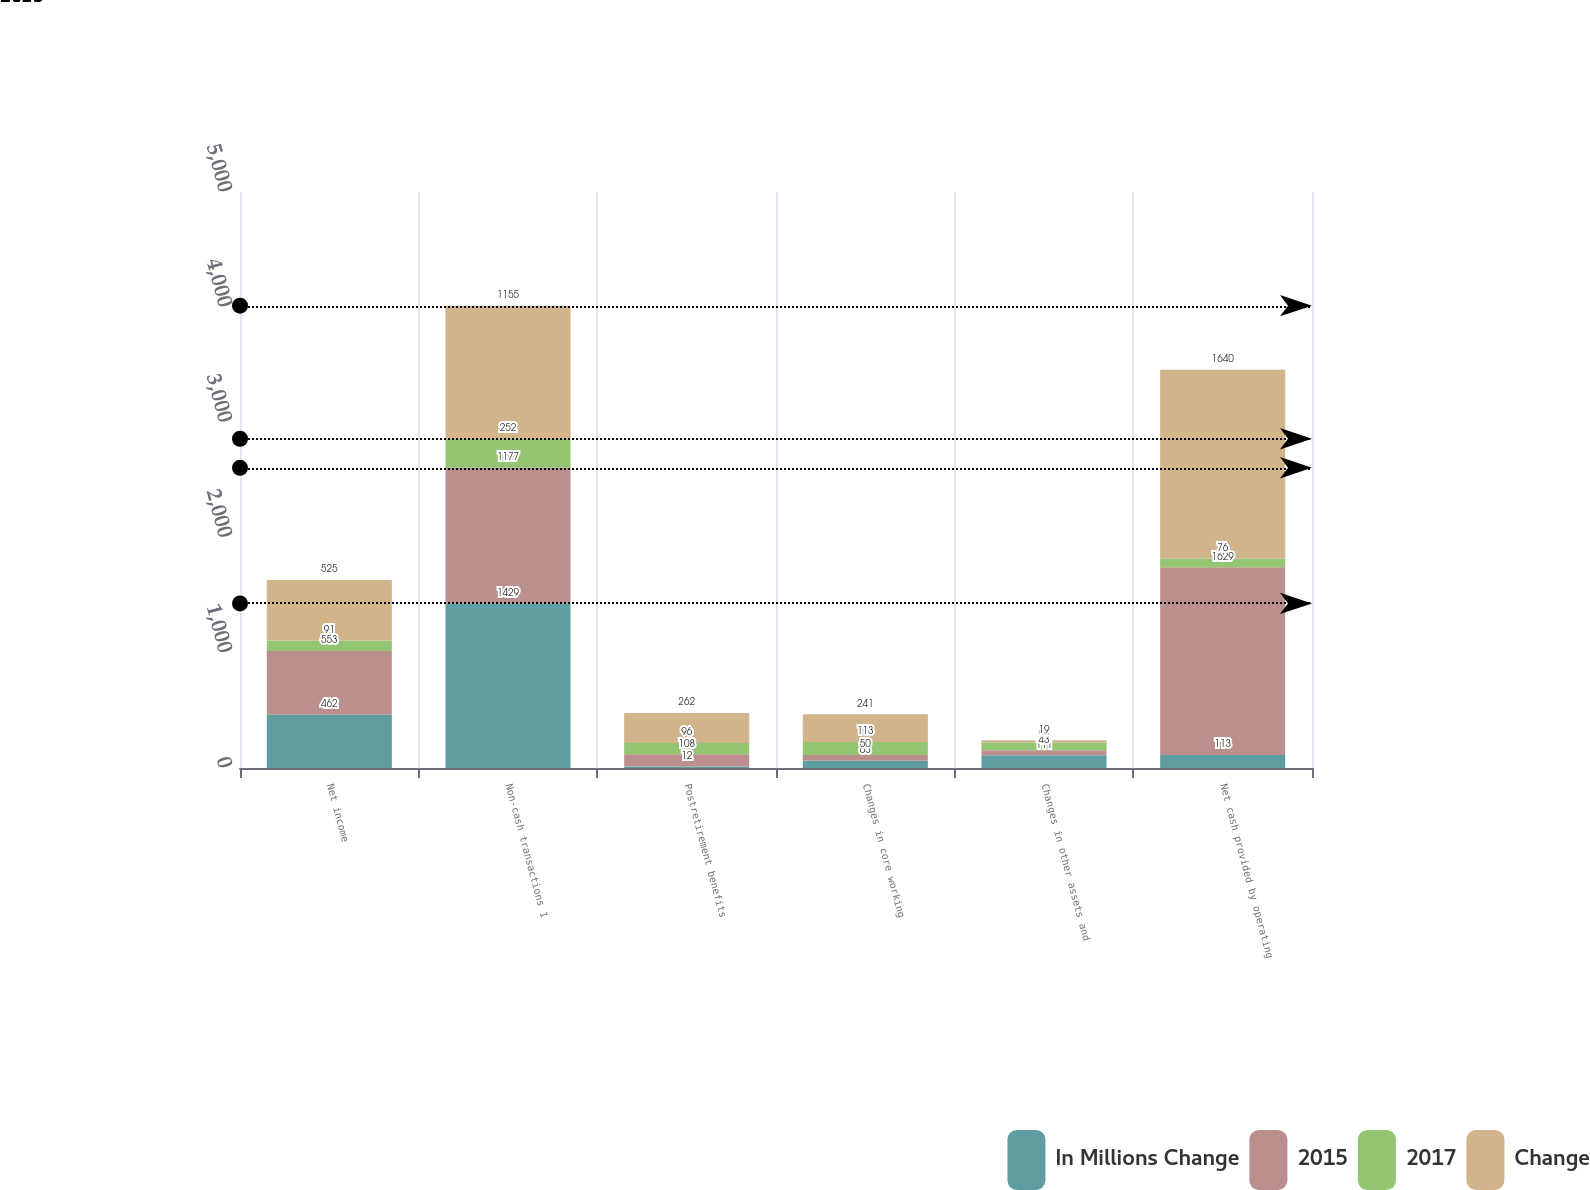Convert chart. <chart><loc_0><loc_0><loc_500><loc_500><stacked_bar_chart><ecel><fcel>Net income<fcel>Non-cash transactions 1<fcel>Postretirement benefits<fcel>Changes in core working<fcel>Changes in other assets and<fcel>Net cash provided by operating<nl><fcel>In Millions Change<fcel>462<fcel>1429<fcel>12<fcel>63<fcel>111<fcel>113<nl><fcel>2015<fcel>553<fcel>1177<fcel>108<fcel>50<fcel>43<fcel>1629<nl><fcel>2017<fcel>91<fcel>252<fcel>96<fcel>113<fcel>68<fcel>76<nl><fcel>Change<fcel>525<fcel>1155<fcel>262<fcel>241<fcel>19<fcel>1640<nl></chart> 